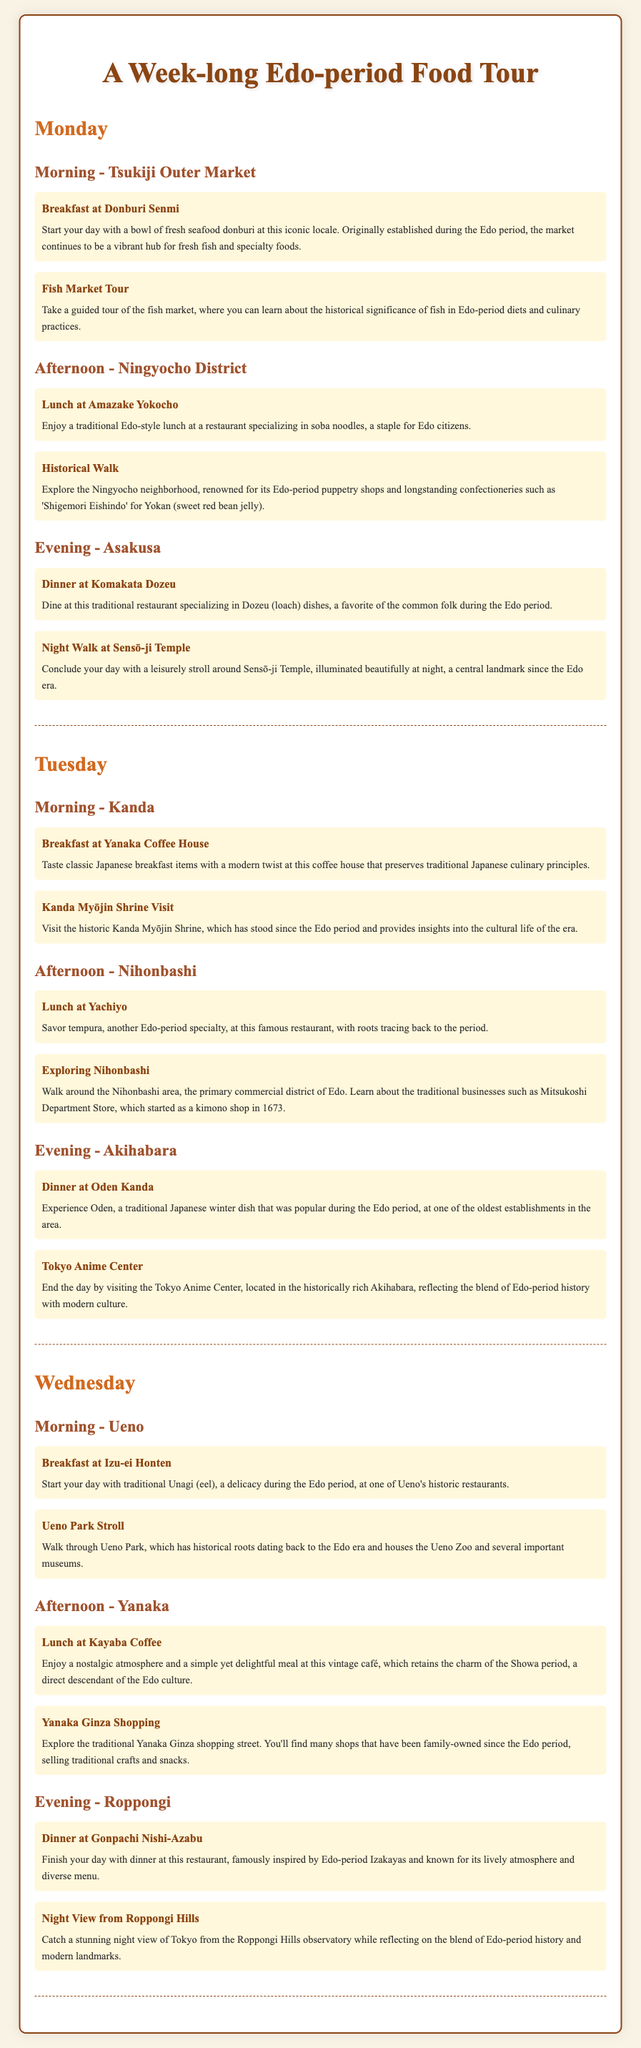What is the first location visited on Monday? The first location visited on Monday is Donburi Senmi for breakfast at Tsukiji Outer Market.
Answer: Donburi Senmi What type of dish is served at Komakata Dozeu? The dish served at Komakata Dozeu is Dozeu (loach), which was a favorite of the common folk during the Edo period.
Answer: Dozeu What historical significance is explored during the Fish Market Tour? The Fish Market Tour explores the historical significance of fish in Edo-period diets and culinary practices.
Answer: Historical significance of fish How many days does the itinerary cover? The itinerary is outlined for a total of three days, Monday, Tuesday, and Wednesday.
Answer: Three days What traditional food is featured at Yachiyo? Yachiyo specializes in tempura, which is another specialty from the Edo period.
Answer: Tempura Which shrine is visited on Tuesday morning? The historic shrine visited on Tuesday morning is Kanda Myōjin Shrine.
Answer: Kanda Myōjin Shrine What is the main theme of the itinerary? The main theme of the itinerary is an exploration of authentic Edo-style restaurants and markets with historical context.
Answer: Edo-style food tour Where do guests end their day on Wednesday? Guests conclude their day on Wednesday with a night view from Roppongi Hills.
Answer: Roppongi Hills What is the focus of the Yanaka Ginza shopping activity? The focus of Yanaka Ginza shopping activity is on traditional crafts and snacks sold by family-owned shops since the Edo period.
Answer: Traditional crafts and snacks 